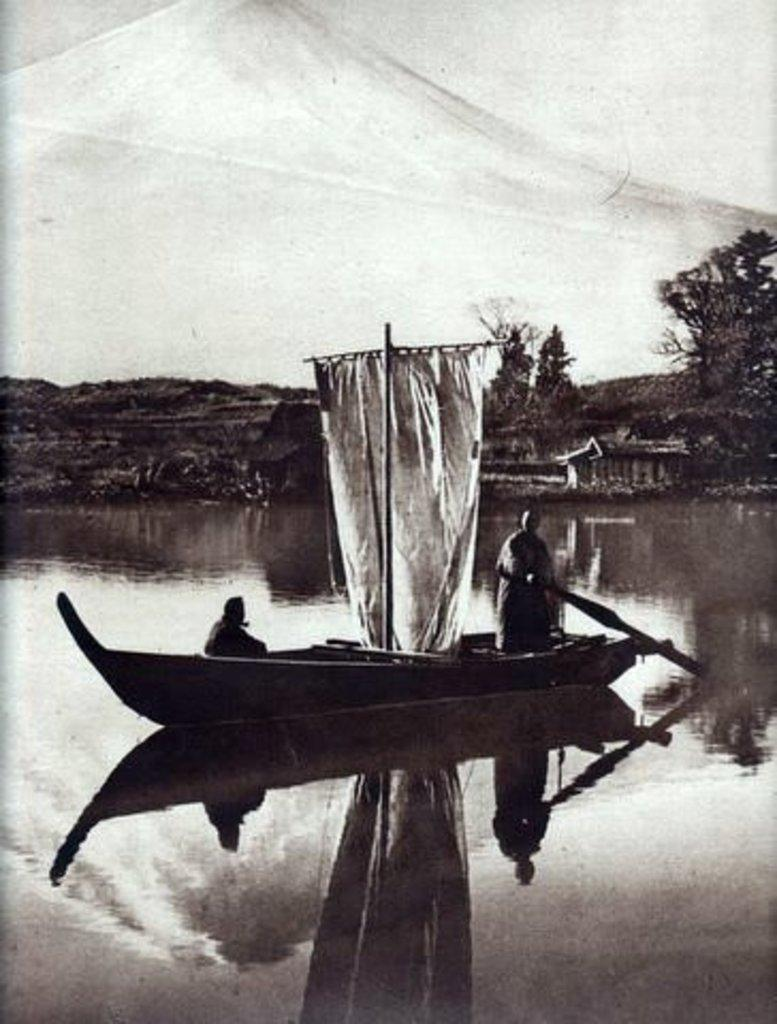What is the color scheme of the image? The image is black and white. How many people are in the boat in the image? There are two people in a boat in the image. What is the boat situated on? The boat is on the surface of water. What can be seen in the background of the image? There are trees and a mountain visible in the background. What type of minister is present in the image? There is no minister present in the image; it features a boat with two people on the water. How does the person in the boat control the water? The person in the boat does not control the water; the water is a natural element that surrounds the boat. 